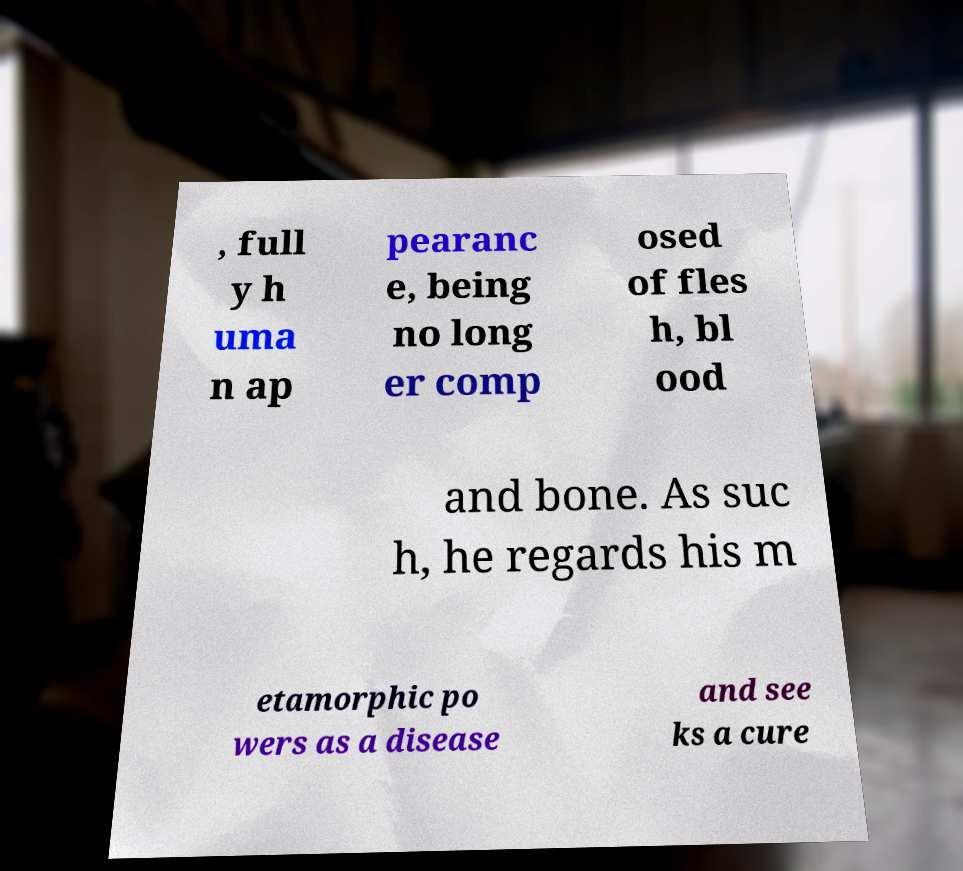Can you read and provide the text displayed in the image?This photo seems to have some interesting text. Can you extract and type it out for me? , full y h uma n ap pearanc e, being no long er comp osed of fles h, bl ood and bone. As suc h, he regards his m etamorphic po wers as a disease and see ks a cure 